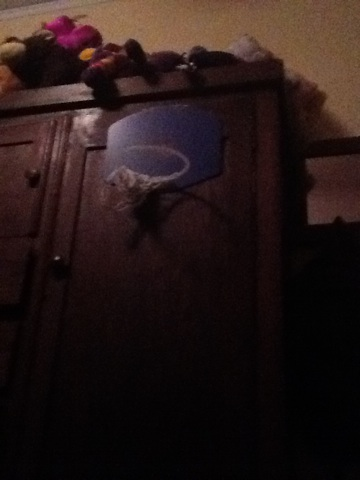How do you think this basketball hoop was made? The basketball hoop in the image appears to be ingeniously made from a blue plastic basket which might have been cut open on one side and attached using a flexible wire or string to the wooden cabinet. This DIY approach shows creativity and resourcefulness. 